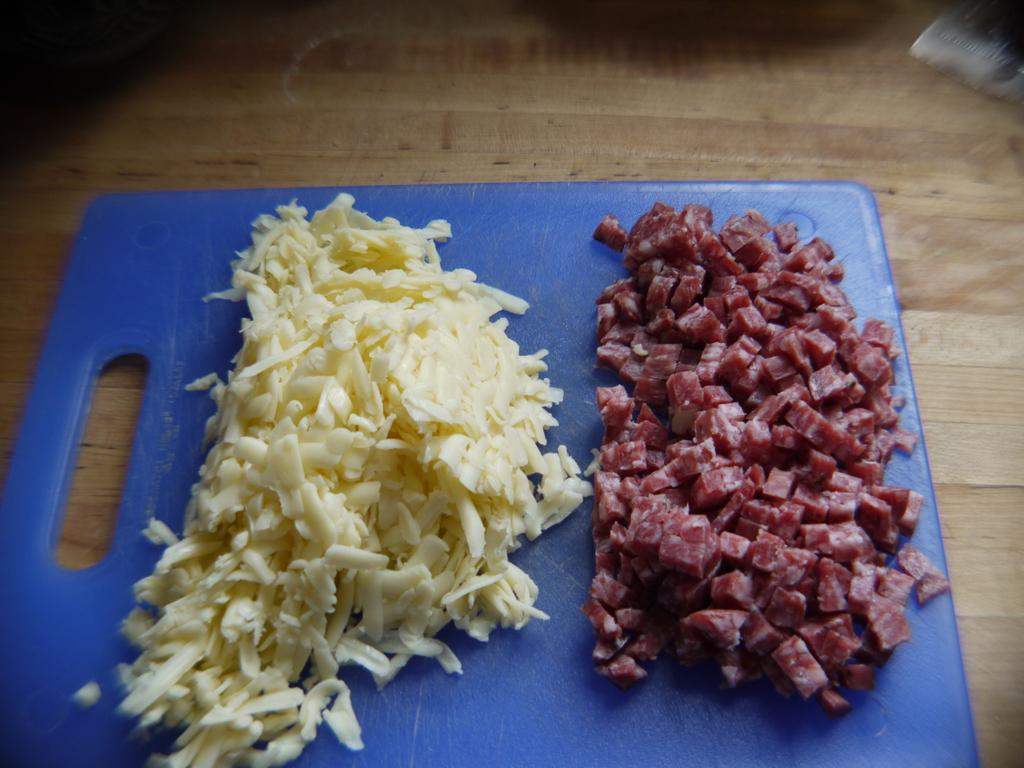What type of food items can be seen in the image? There are food items in the image, including cut meat. What color is the chopping board in the image? The chopping board in the image is blue. What is the chopping board placed on in the image? The chopping board is placed on a wooden surface. Can you see a ghost in the image? No, there is no ghost present in the image. What direction should you look to find the fight in the image? There is no fight present in the image. 